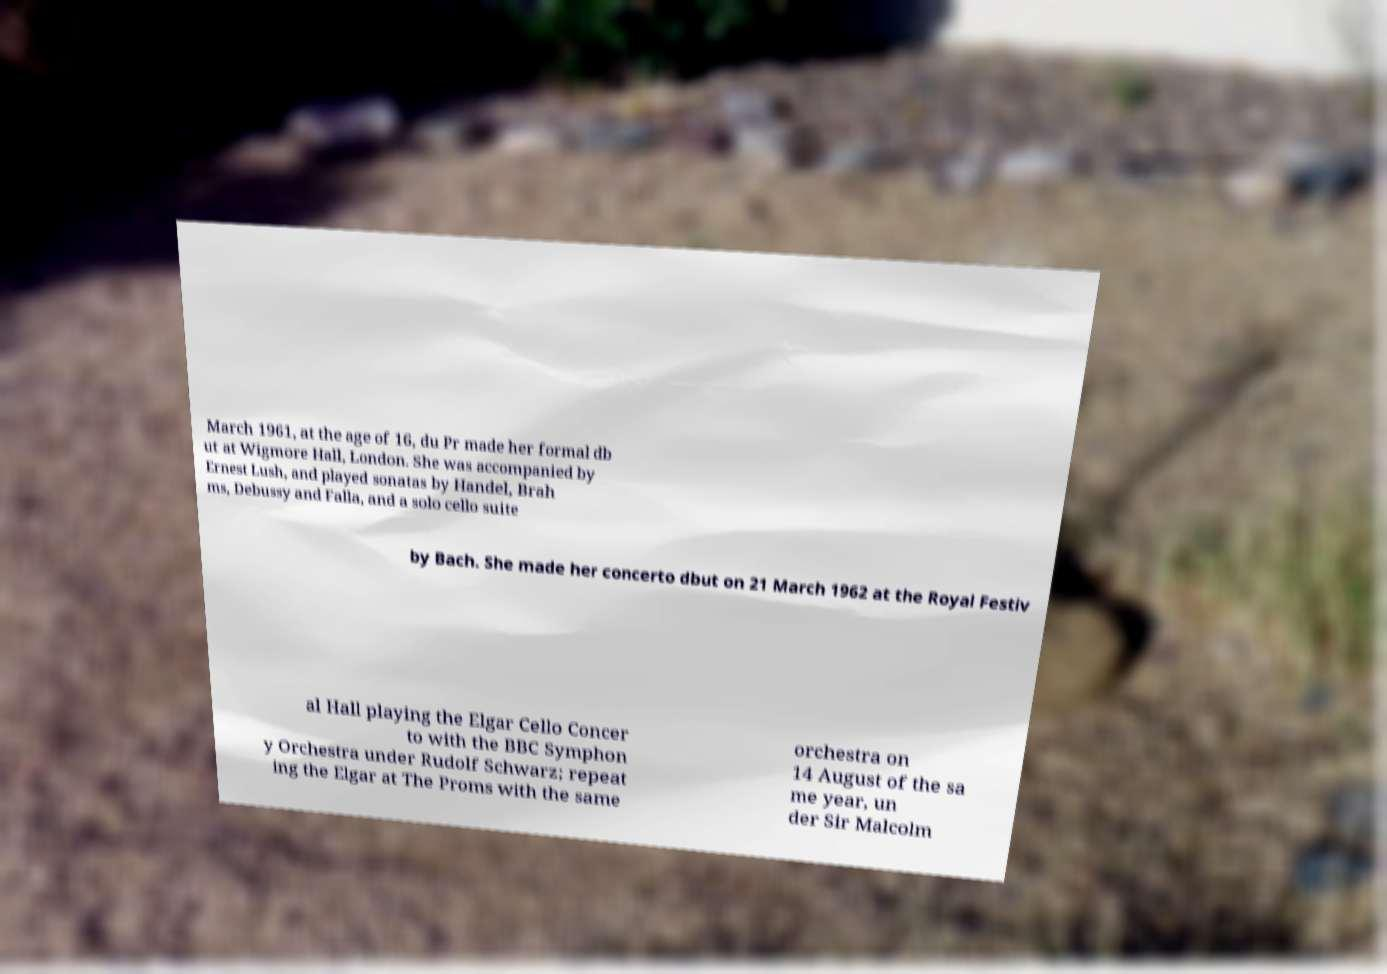Could you extract and type out the text from this image? March 1961, at the age of 16, du Pr made her formal db ut at Wigmore Hall, London. She was accompanied by Ernest Lush, and played sonatas by Handel, Brah ms, Debussy and Falla, and a solo cello suite by Bach. She made her concerto dbut on 21 March 1962 at the Royal Festiv al Hall playing the Elgar Cello Concer to with the BBC Symphon y Orchestra under Rudolf Schwarz; repeat ing the Elgar at The Proms with the same orchestra on 14 August of the sa me year, un der Sir Malcolm 